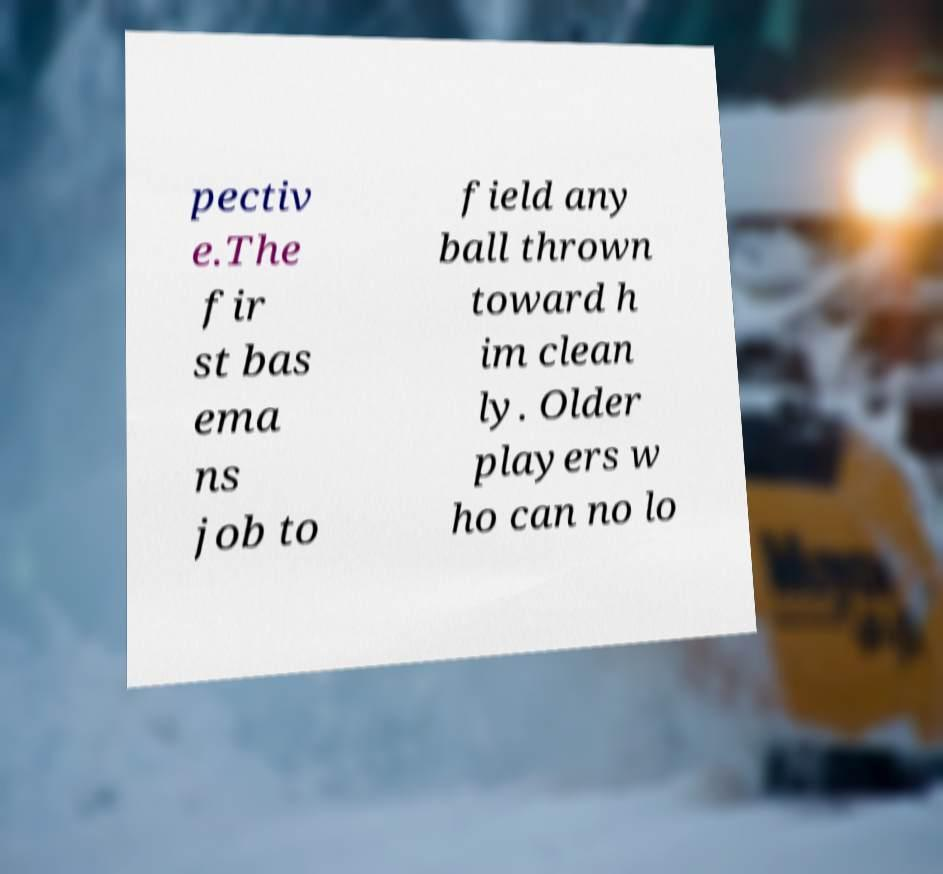Could you extract and type out the text from this image? pectiv e.The fir st bas ema ns job to field any ball thrown toward h im clean ly. Older players w ho can no lo 